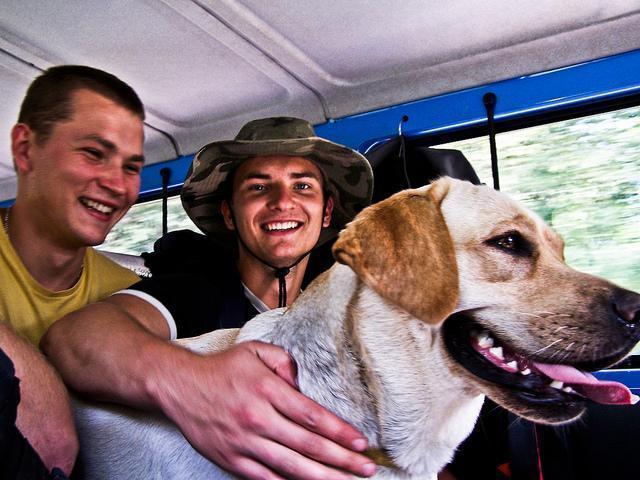What is touching the dog?
Pick the correct solution from the four options below to address the question.
Options: Cat's paw, man's hand, bear's claw, woman's hand. Man's hand. 